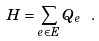<formula> <loc_0><loc_0><loc_500><loc_500>H = \sum _ { e \in E } Q _ { e } \ .</formula> 